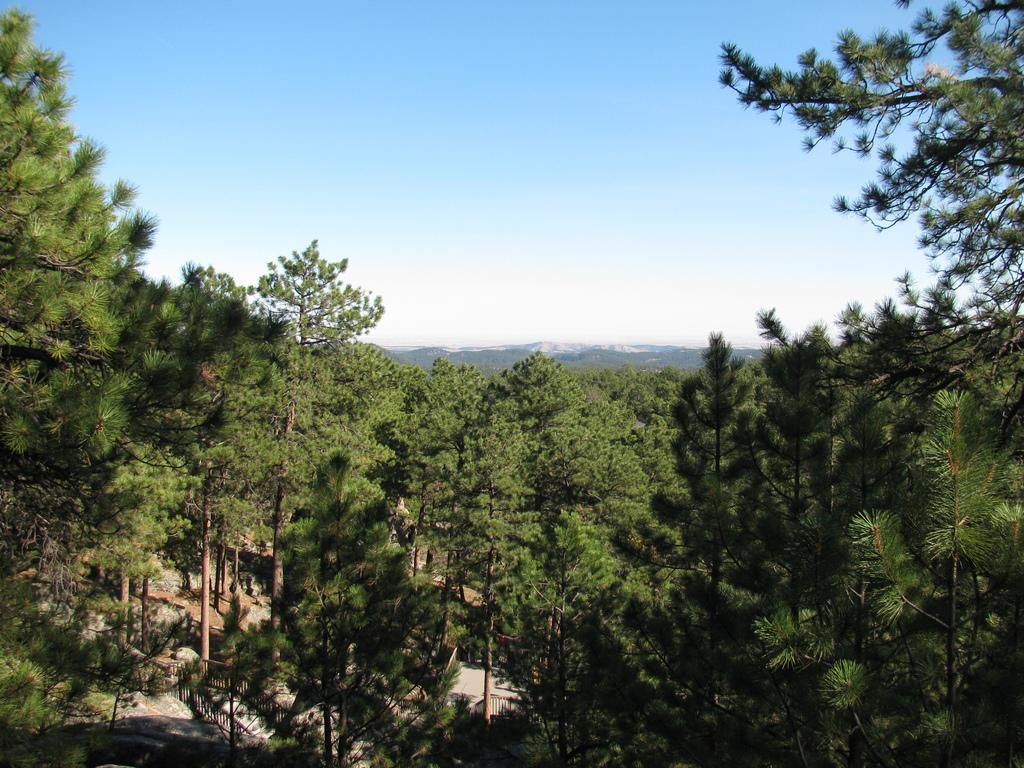What type of vegetation can be seen in the image? There are trees in the image. What natural features can be seen in the distance? There are mountains visible in the background of the image. What part of the natural environment is visible at the top of the image? The sky is visible at the top of the image. What part of the natural environment is visible at the bottom of the image? The ground is visible at the bottom of the image. Can you see any icicles hanging from the trees in the image? There are no icicles visible in the image; the trees appear to be in a non-frozen environment. What type of fabric is draped over the mountains in the image? There is no fabric visible in the image; the mountains are depicted as natural landforms. 